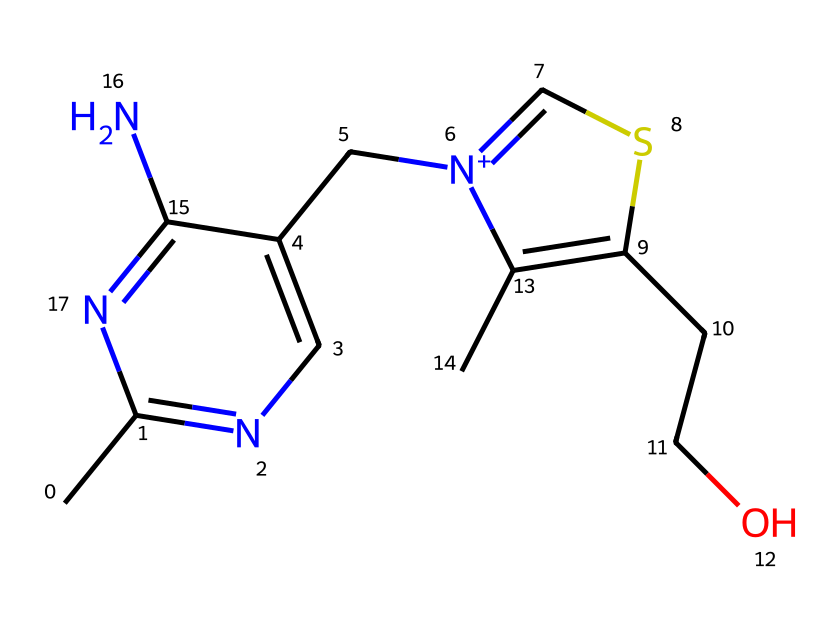how many nitrogen atoms are present in vitamin B1? The chemical structure shows multiple nitrogen atoms present; by counting the 'N' symbols in the SMILES notation, we identify that there are four nitrogen atoms in total.
Answer: four what is the functional group associated with vitamin B1? In the chemical structure, we identify a hydroxyl group (-OH) due to the presence of an oxygen atom bonded to a hydrogen atom. This functional group is characteristic of alcohols and is present in vitamin B1.
Answer: hydroxyl group which elements are present in the structure of vitamin B1? By examining the SMILES representation, we can identify carbon (C), hydrogen (H), nitrogen (N), and oxygen (O) atoms. This analysis reveals that the chemical consists of these four elements.
Answer: carbon, hydrogen, nitrogen, oxygen what type of molecule is vitamin B1 classified as? Vitamin B1 is classified as a water-soluble vitamin, based on its structure which indicates ability to interact with water due to polar functional groups like hydroxyl.
Answer: water-soluble vitamin how many rings are present in the structure of vitamin B1? Analyzing the chemical structure reveals two rings in the molecule that can be visually identified by looking for cyclical arrangements of atoms. These rings enhance its stability and function.
Answer: two what is the molecular weight approximation of vitamin B1? To calculate the molecular weight, we sum the atomic weights of all atoms listed in the SMILES notation. The approximate molecular weight of vitamin B1 based on its structural components is around 265 g/mol.
Answer: 265 g/mol 